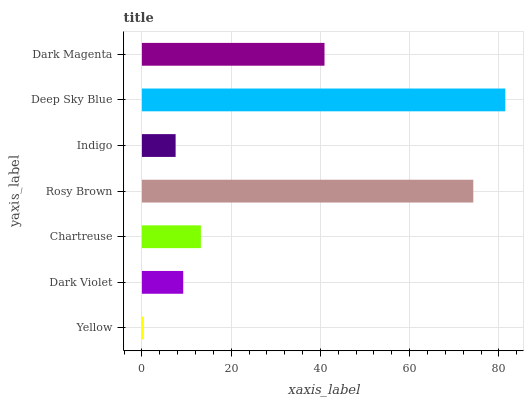Is Yellow the minimum?
Answer yes or no. Yes. Is Deep Sky Blue the maximum?
Answer yes or no. Yes. Is Dark Violet the minimum?
Answer yes or no. No. Is Dark Violet the maximum?
Answer yes or no. No. Is Dark Violet greater than Yellow?
Answer yes or no. Yes. Is Yellow less than Dark Violet?
Answer yes or no. Yes. Is Yellow greater than Dark Violet?
Answer yes or no. No. Is Dark Violet less than Yellow?
Answer yes or no. No. Is Chartreuse the high median?
Answer yes or no. Yes. Is Chartreuse the low median?
Answer yes or no. Yes. Is Yellow the high median?
Answer yes or no. No. Is Rosy Brown the low median?
Answer yes or no. No. 